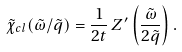Convert formula to latex. <formula><loc_0><loc_0><loc_500><loc_500>\tilde { \chi } _ { c l } ( \tilde { \omega } / \tilde { q } ) = \frac { 1 } { 2 t } \, Z ^ { \prime } \left ( \frac { \tilde { \omega } } { 2 \tilde { q } } \right ) .</formula> 